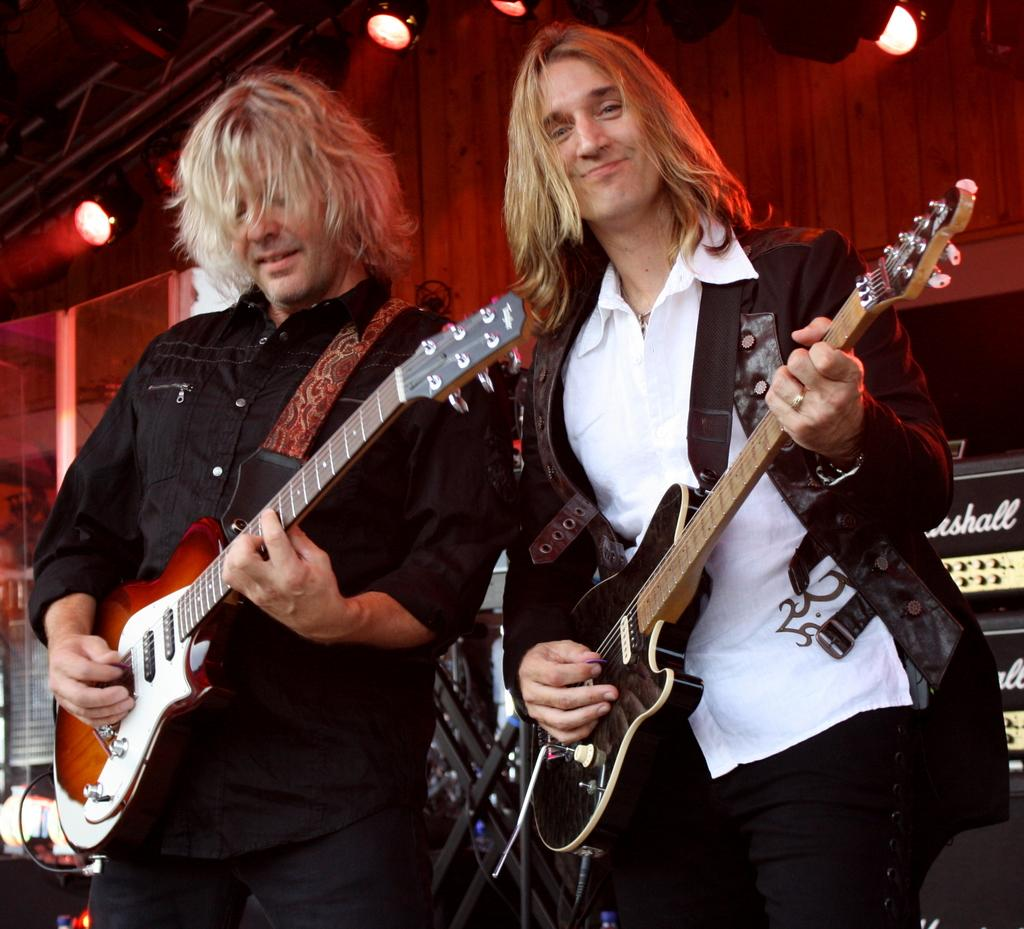How many people are in the image? There are two persons in the image. What are the persons holding in the image? Both persons are holding a guitar. Can you describe the clothing of the first person? The first person is wearing a black shirt. How about the second person? The second person is wearing a black jacket. What additional feature can be seen at the top of the image? There are focusing lights visible at the top of the image. What type of protest is taking place in the image? There is no protest present in the image; it features two persons holding guitars. Can you tell me how many coils are visible in the image? There are no coils visible in the image. 